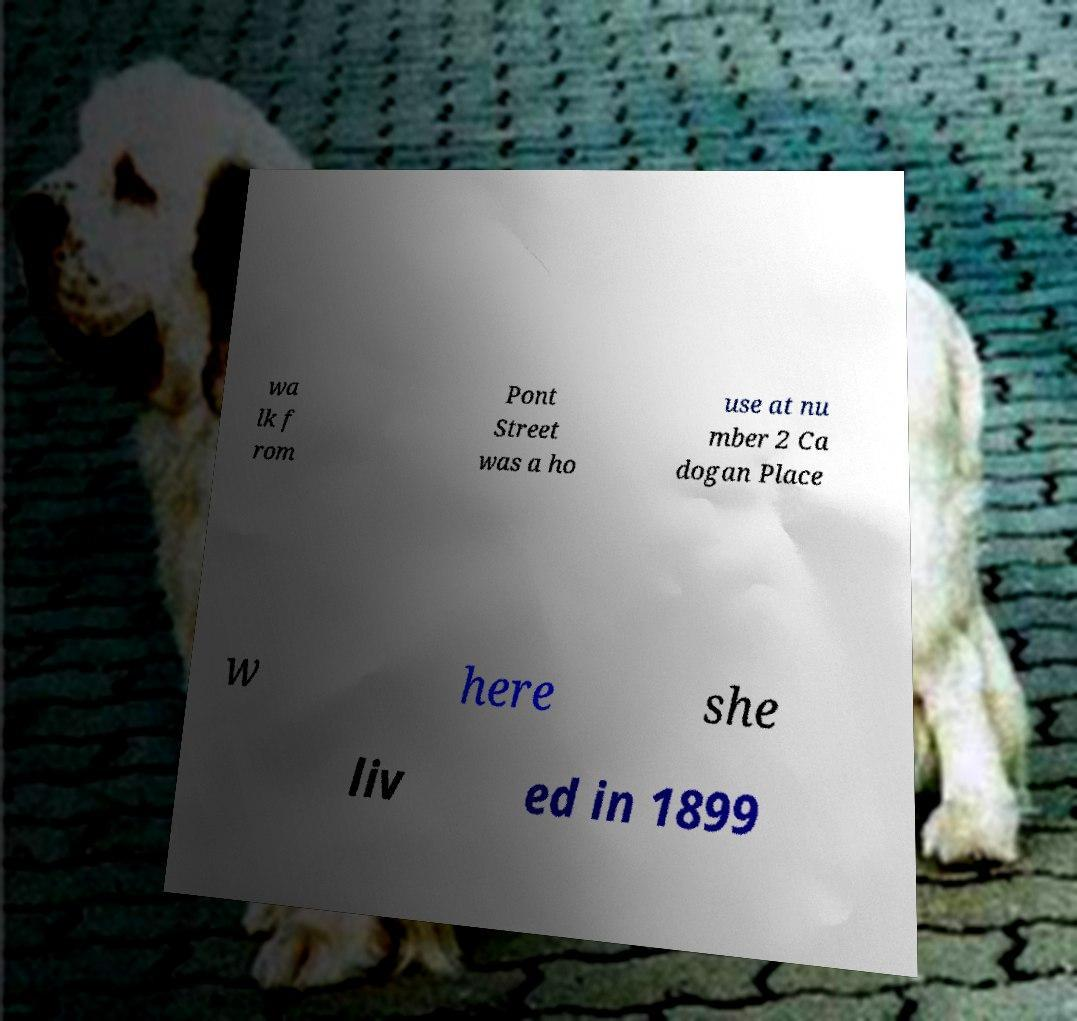Can you accurately transcribe the text from the provided image for me? wa lk f rom Pont Street was a ho use at nu mber 2 Ca dogan Place w here she liv ed in 1899 